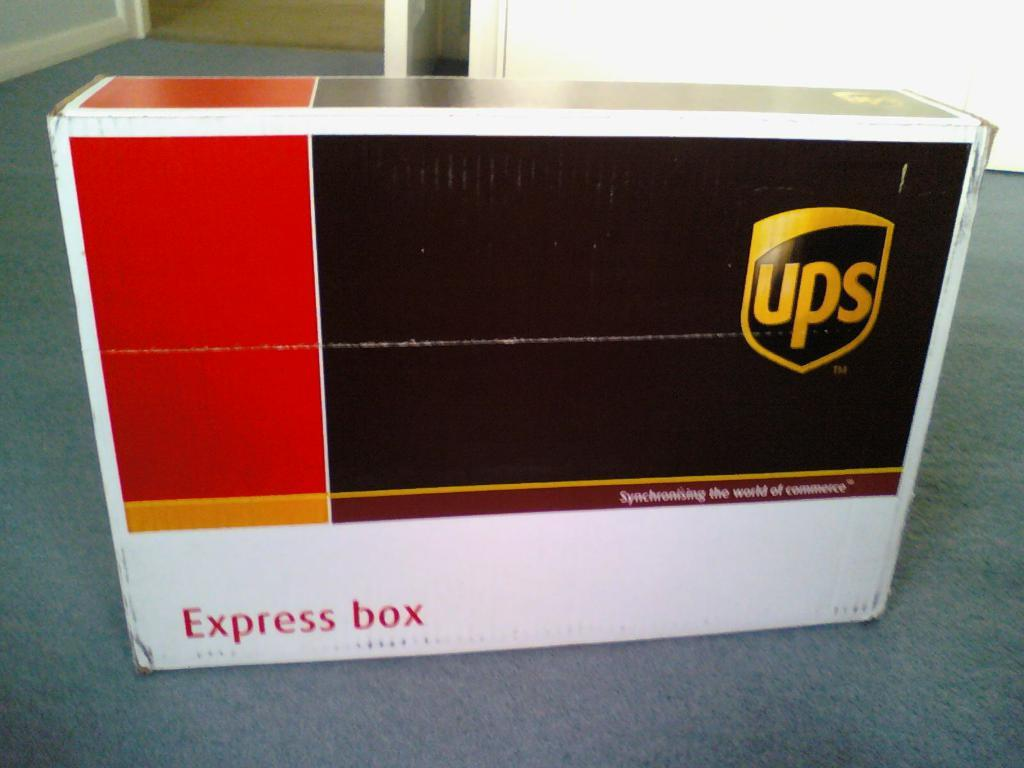<image>
Describe the image concisely. A black, red and white UPS express box on a floor. 